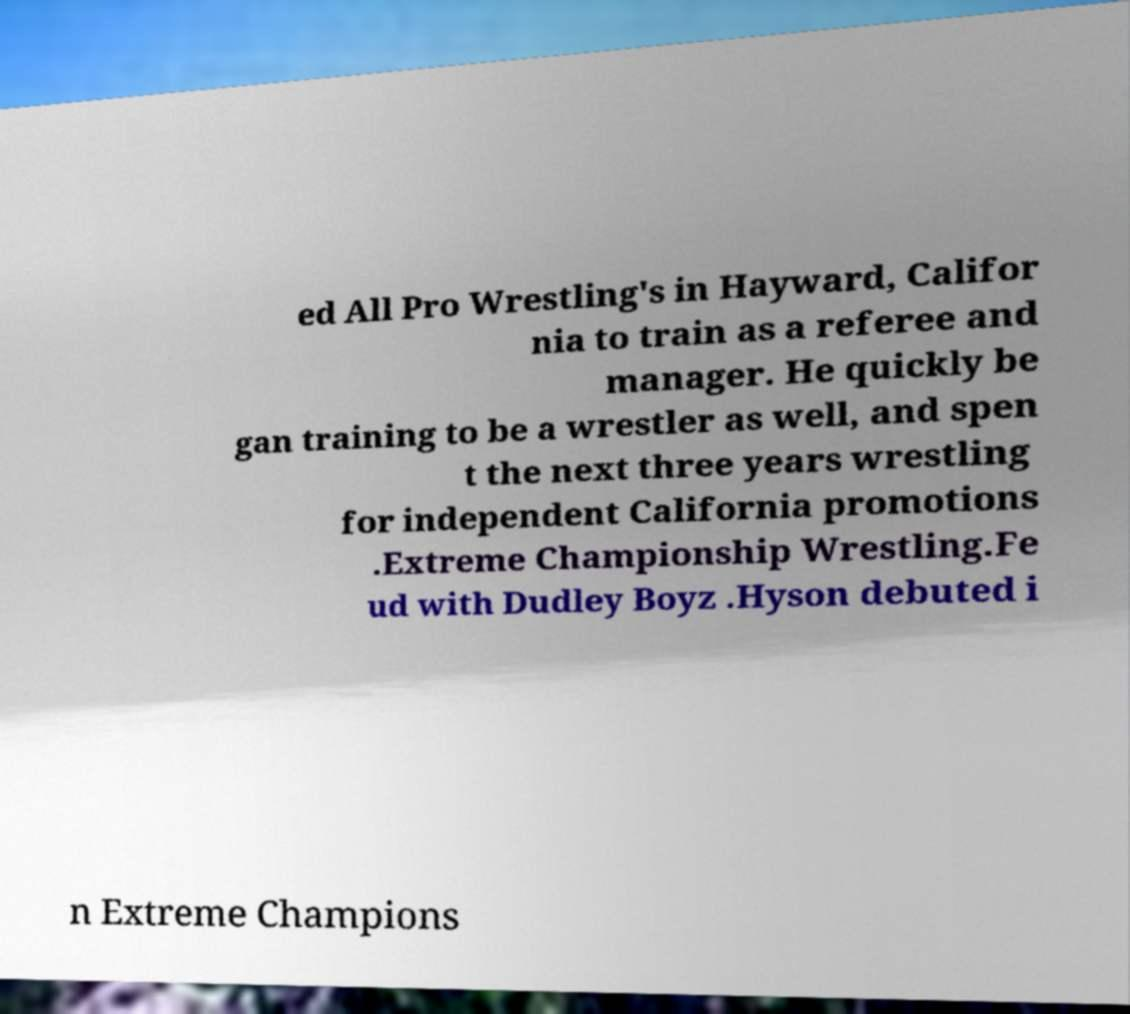What messages or text are displayed in this image? I need them in a readable, typed format. ed All Pro Wrestling's in Hayward, Califor nia to train as a referee and manager. He quickly be gan training to be a wrestler as well, and spen t the next three years wrestling for independent California promotions .Extreme Championship Wrestling.Fe ud with Dudley Boyz .Hyson debuted i n Extreme Champions 